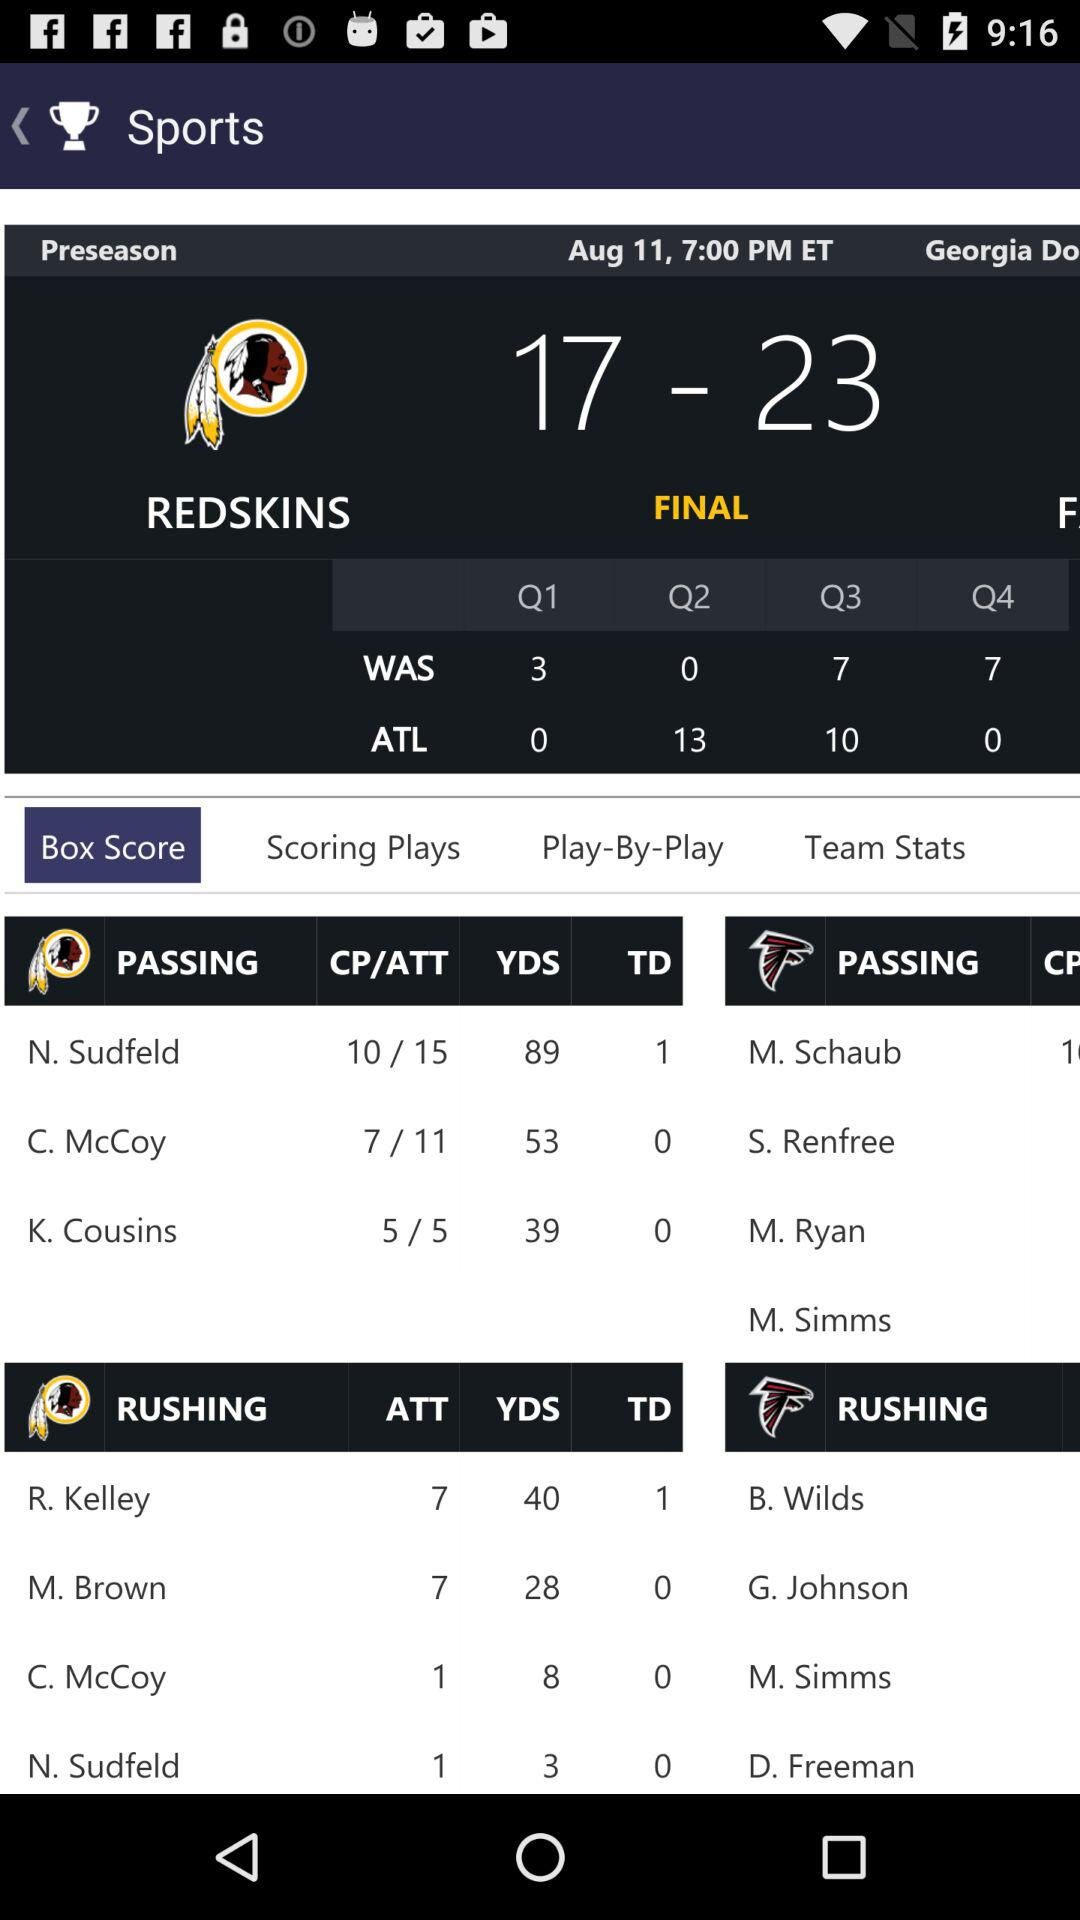What is the number of passing yards for K. Cousins? The number of passing yards for K. Cousins is 39. 